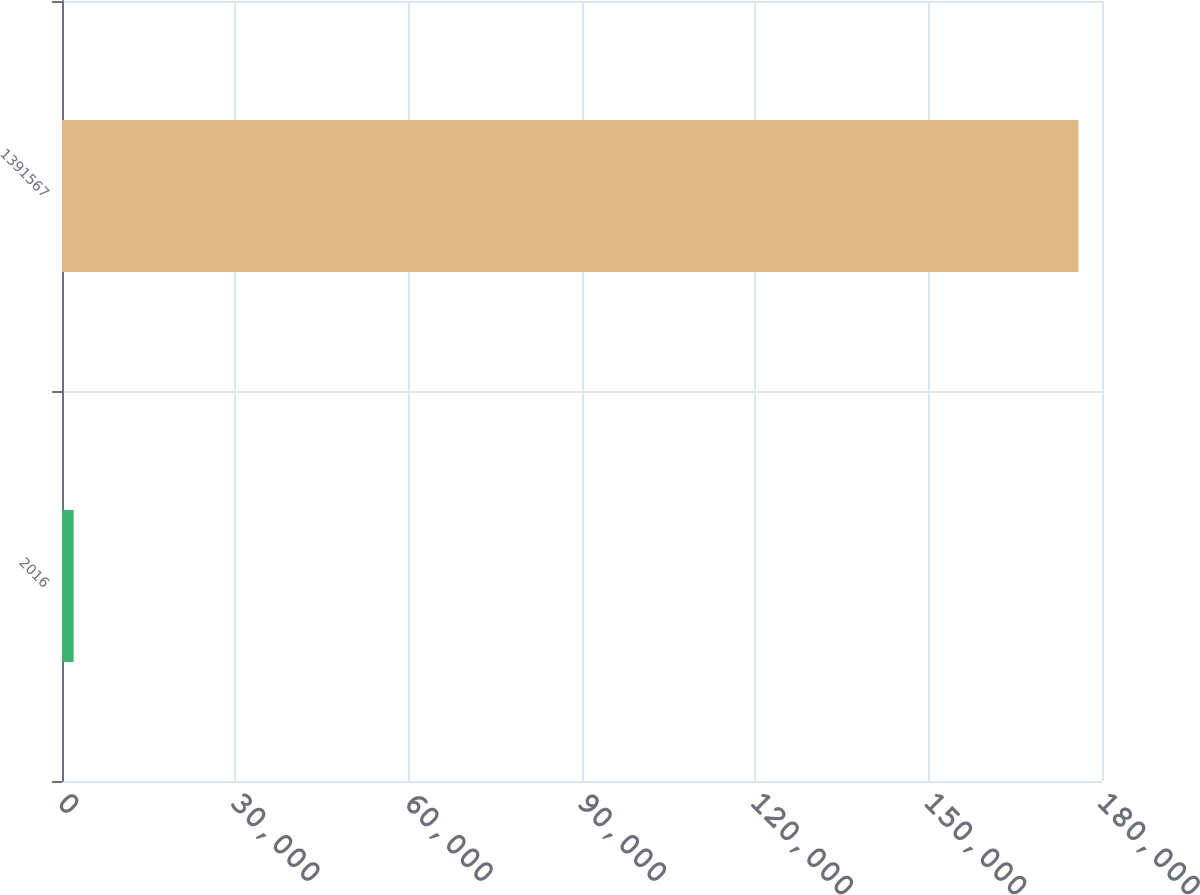Convert chart. <chart><loc_0><loc_0><loc_500><loc_500><bar_chart><fcel>2016<fcel>1391567<nl><fcel>2014<fcel>175902<nl></chart> 